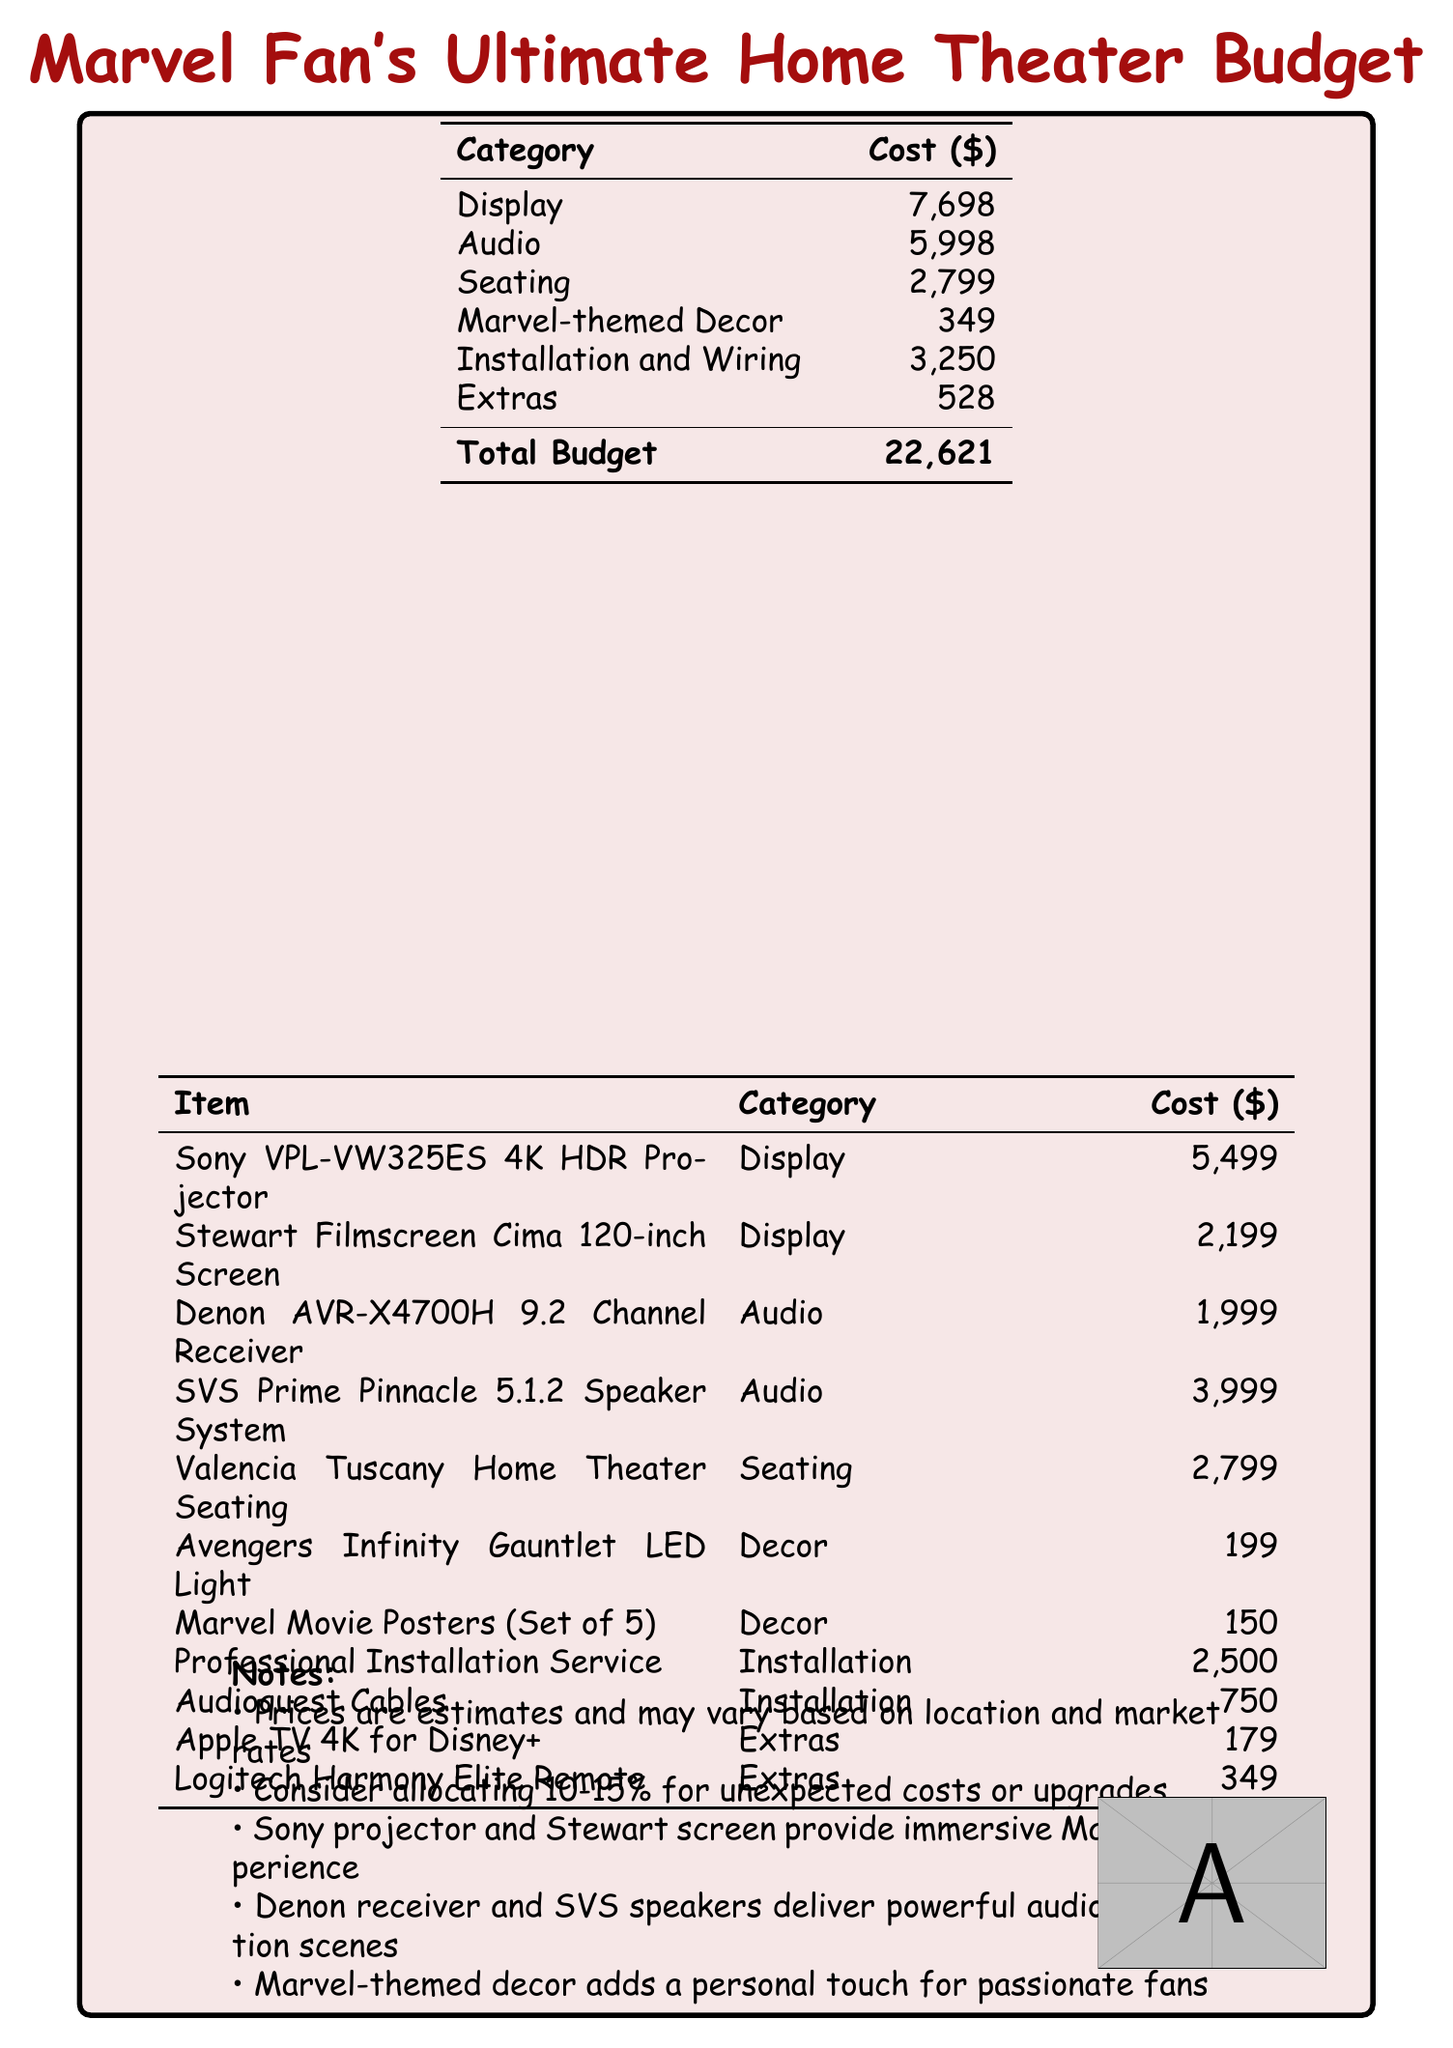What is the total budget? The total budget is clearly listed at the bottom of the cost table as $22,621.
Answer: $22,621 How much does the Sony projector cost? The cost of the Sony VPL-VW325ES 4K HDR Projector is specified in the item breakdown as $5,499.
Answer: $5,499 What is the cost of Marvel-themed Decor? The cost allocated for Marvel-themed Decor is noted as $349 in the budget.
Answer: $349 What is the cost of professional installation service? The professional installation service cost is also detailed in the installation breakdown and is $2,500.
Answer: $2,500 Which item has the highest cost? The Sony VPL-VW325ES 4K HDR Projector is the highest priced item listed in the document at $5,499.
Answer: Sony VPL-VW325ES 4K HDR Projector What percentage should be allocated for unexpected costs? The document suggests allocating 10-15% for unexpected costs or upgrades.
Answer: 10-15% How many items are listed under the Audio category? The budget document shows a total of two specific items listed under the Audio category, the Denon receiver and the speaker system.
Answer: 2 What decorative item has a cost of $199? The item that costs $199 is the Avengers Infinity Gauntlet LED Light as specified in the decor section.
Answer: Avengers Infinity Gauntlet LED Light 